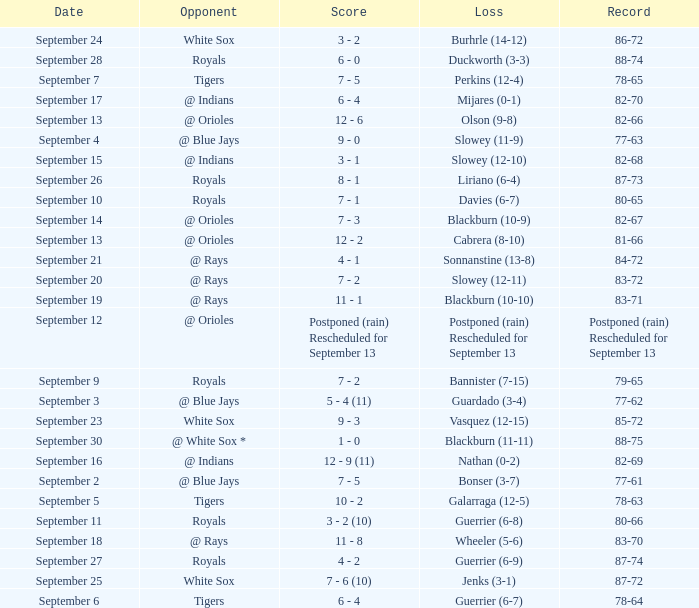What opponent has the record of 78-63? Tigers. 